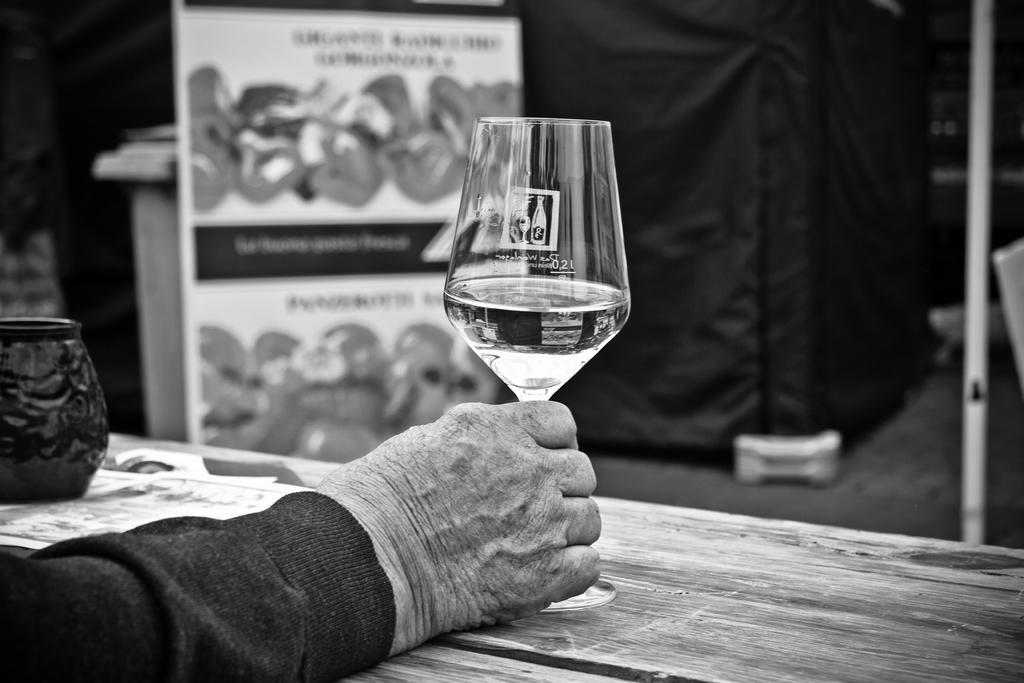Could you give a brief overview of what you see in this image? A person is holding a glass. Bottom right side of the image there is a table. At the top of the image there is a banner. 